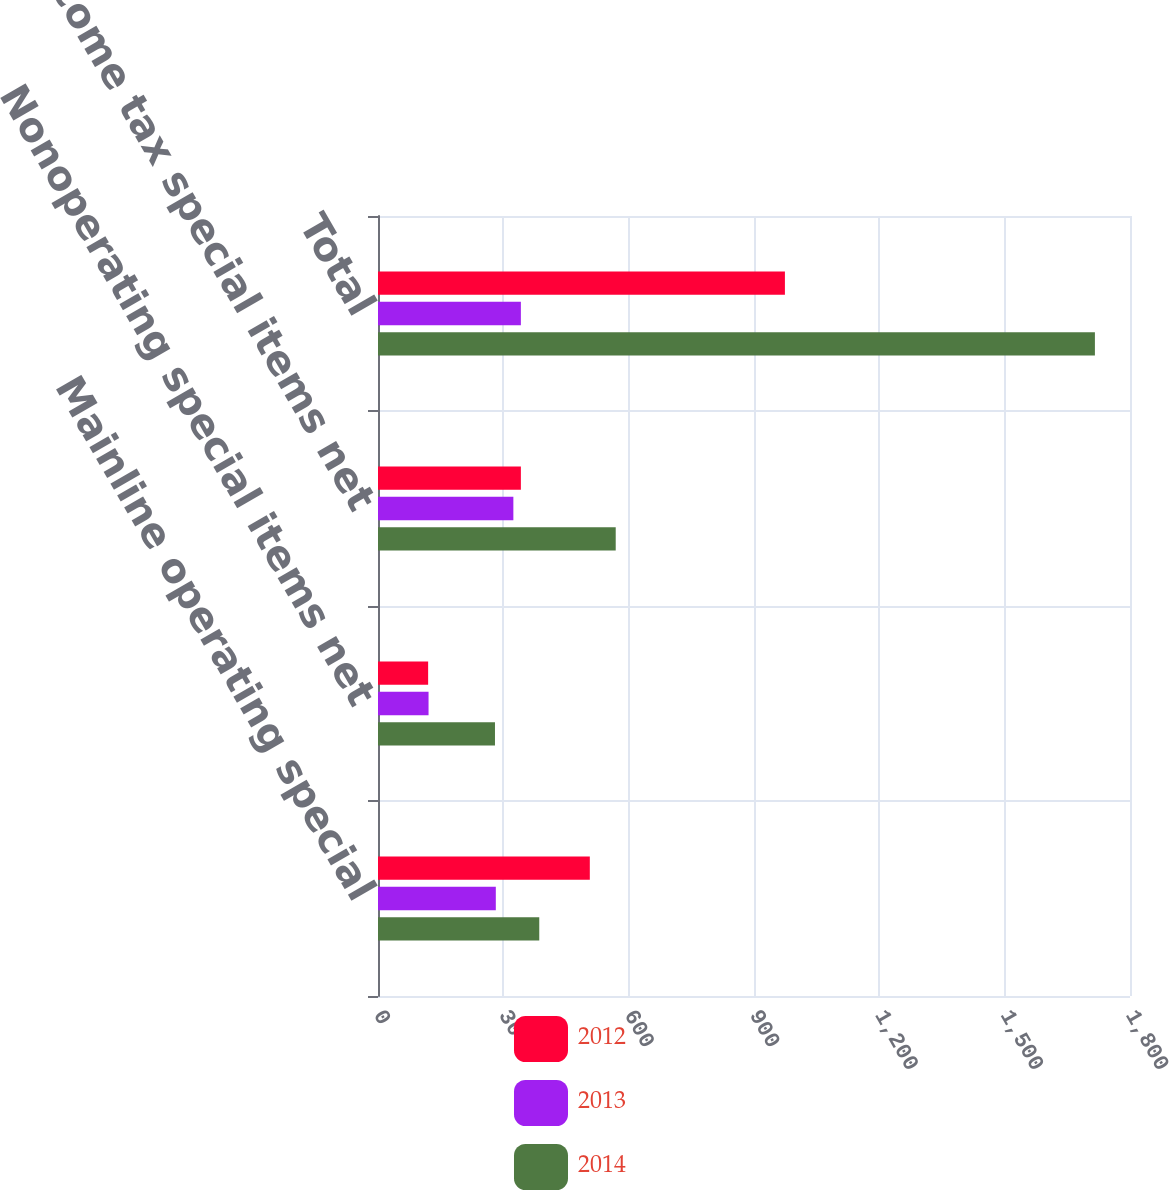<chart> <loc_0><loc_0><loc_500><loc_500><stacked_bar_chart><ecel><fcel>Mainline operating special<fcel>Nonoperating special items net<fcel>Income tax special items net<fcel>Total<nl><fcel>2012<fcel>507<fcel>120<fcel>342<fcel>974<nl><fcel>2013<fcel>282<fcel>121<fcel>324<fcel>342<nl><fcel>2014<fcel>386<fcel>280<fcel>569<fcel>1716<nl></chart> 